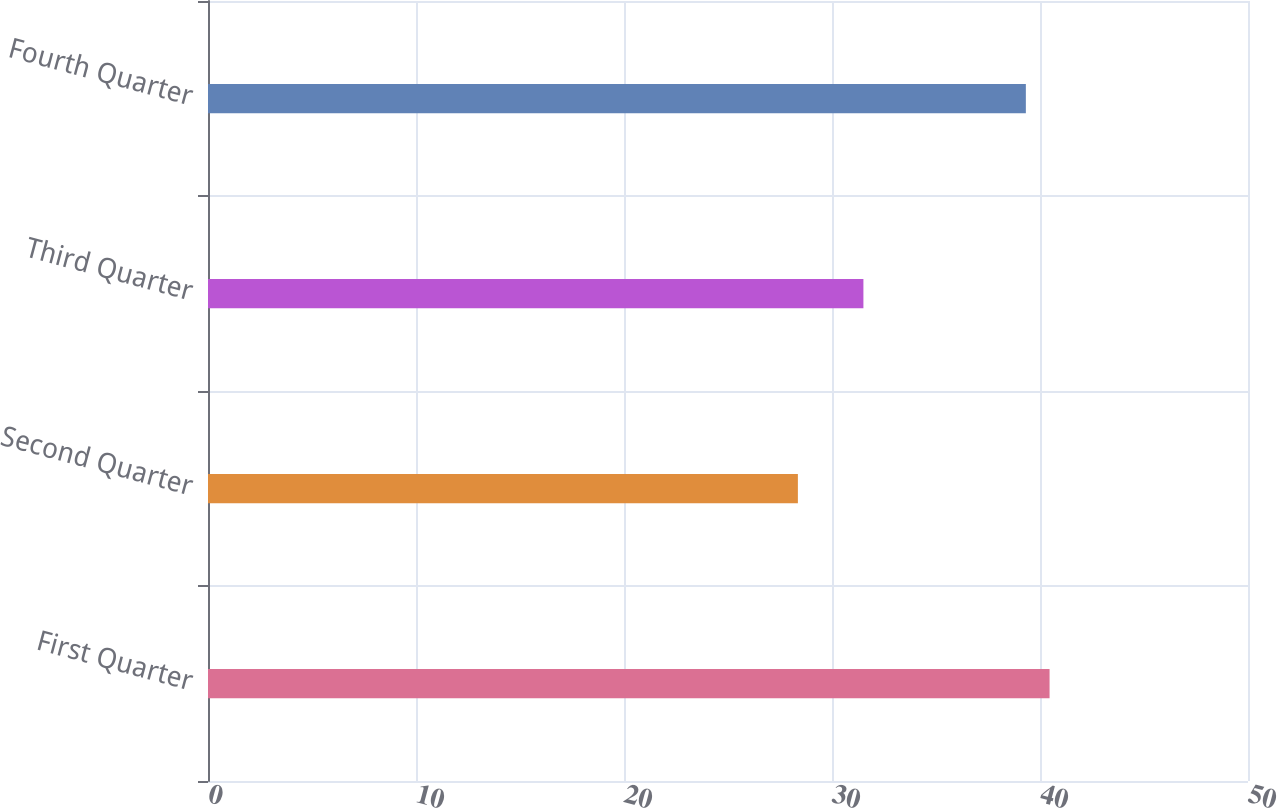Convert chart. <chart><loc_0><loc_0><loc_500><loc_500><bar_chart><fcel>First Quarter<fcel>Second Quarter<fcel>Third Quarter<fcel>Fourth Quarter<nl><fcel>40.46<fcel>28.36<fcel>31.51<fcel>39.32<nl></chart> 